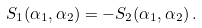Convert formula to latex. <formula><loc_0><loc_0><loc_500><loc_500>S _ { 1 } ( \alpha _ { 1 } , \alpha _ { 2 } ) = - S _ { 2 } ( \alpha _ { 1 } , \alpha _ { 2 } ) \, .</formula> 